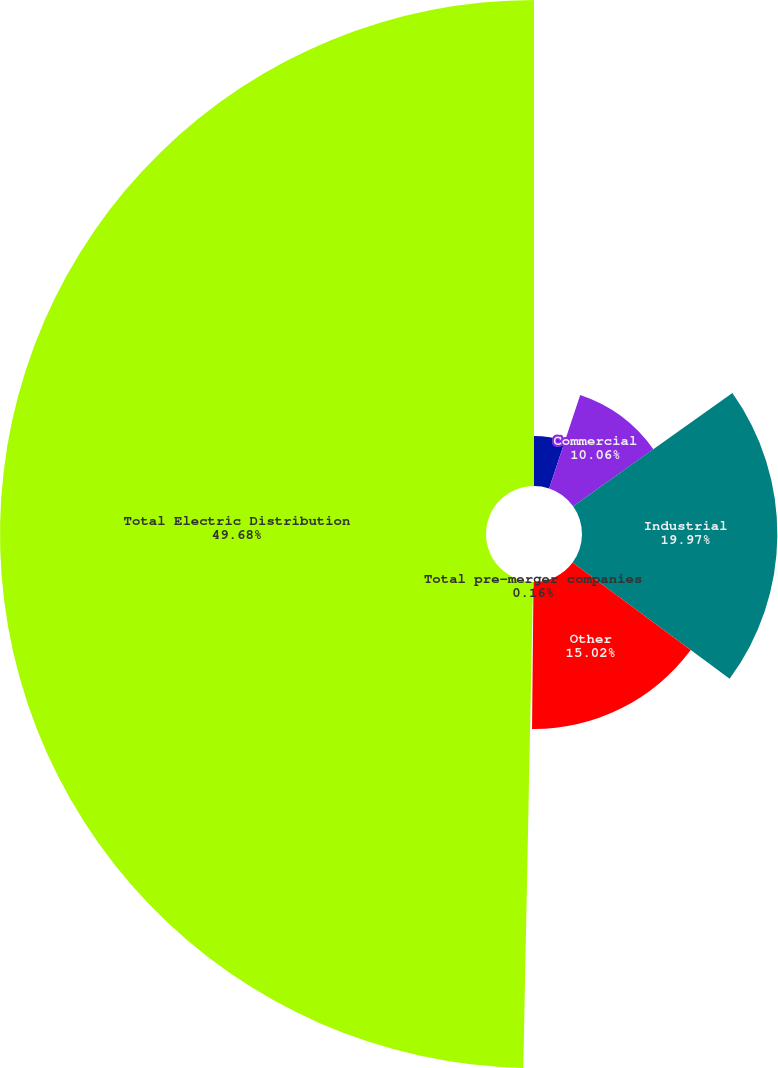<chart> <loc_0><loc_0><loc_500><loc_500><pie_chart><fcel>Residential<fcel>Commercial<fcel>Industrial<fcel>Other<fcel>Total pre-merger companies<fcel>Total Electric Distribution<nl><fcel>5.11%<fcel>10.06%<fcel>19.97%<fcel>15.02%<fcel>0.16%<fcel>49.68%<nl></chart> 